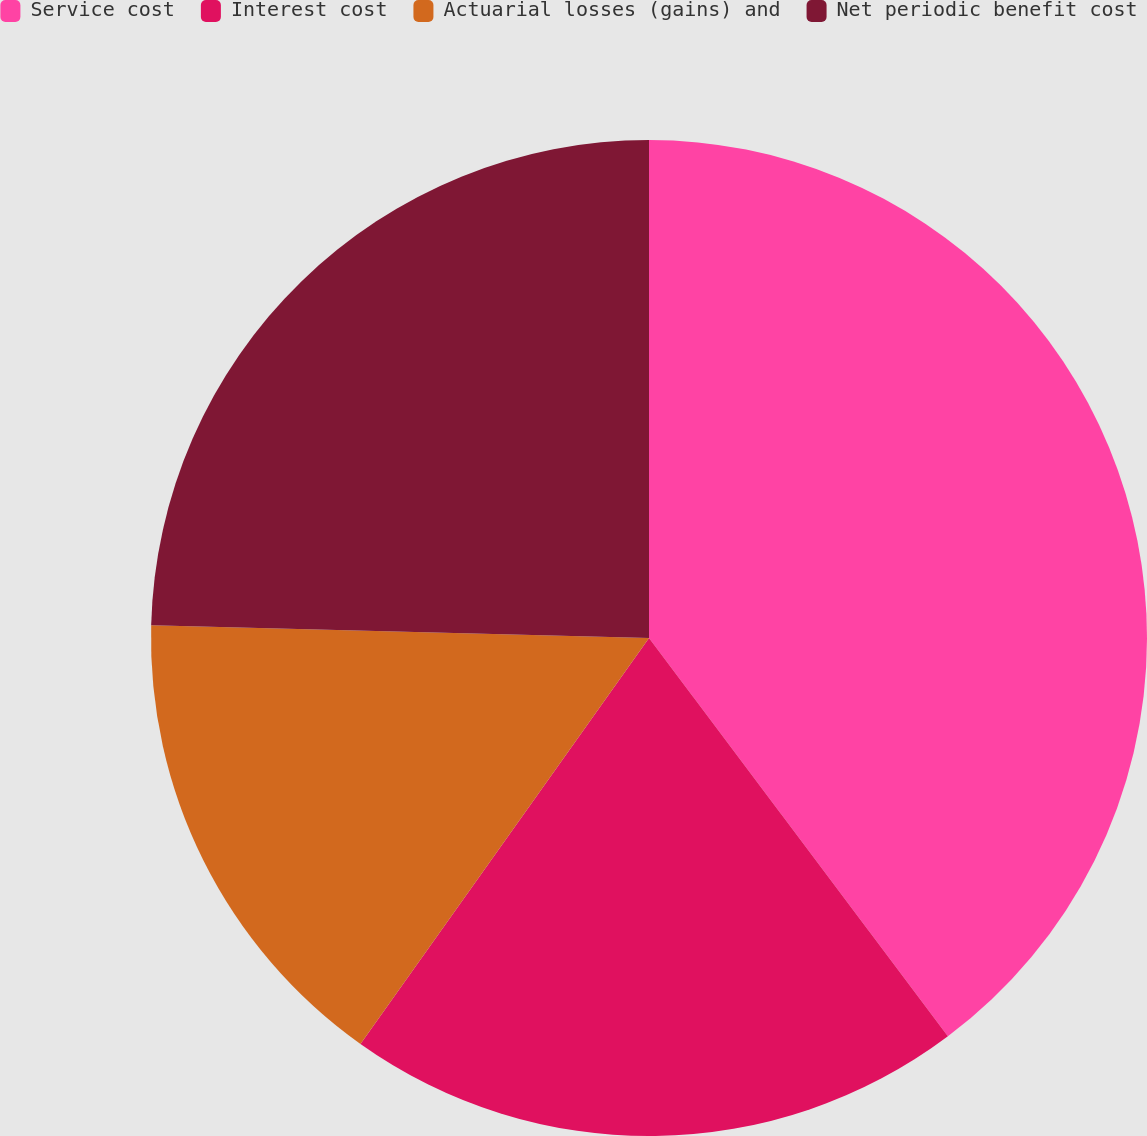<chart> <loc_0><loc_0><loc_500><loc_500><pie_chart><fcel>Service cost<fcel>Interest cost<fcel>Actuarial losses (gains) and<fcel>Net periodic benefit cost<nl><fcel>39.75%<fcel>20.08%<fcel>15.57%<fcel>24.59%<nl></chart> 